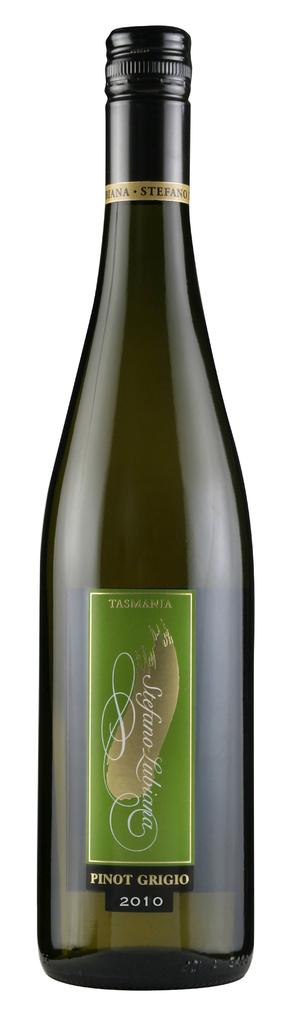What object can be seen in the picture? There is a bottle in the picture. What information is provided on the bottle? There is text and numbers on the label of the bottle. What flavor of duck is depicted on the label of the bottle? There is no duck, flavored or otherwise, depicted on the label of the bottle. 